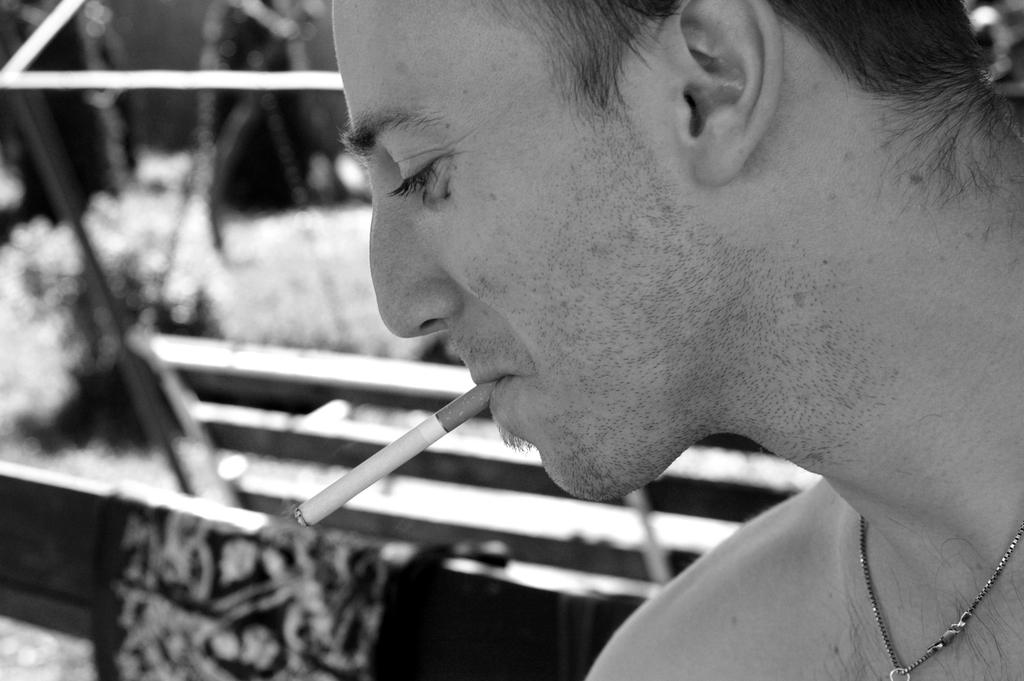What is the position of the man's face in the image? The man has a side view of his face in the image. What is the man doing with his mouth in the image? The man is holding a cigarette in his mouth in the image. Can you describe the objects beside the man in the image? The objects beside the man are not clearly visible in the image. What type of quince is the man using to power his device in the image? There is no quince or device present in the image. How does the man provide support to the objects beside him in the image? The man is not providing support to any objects in the image, as they are not clearly visible. 